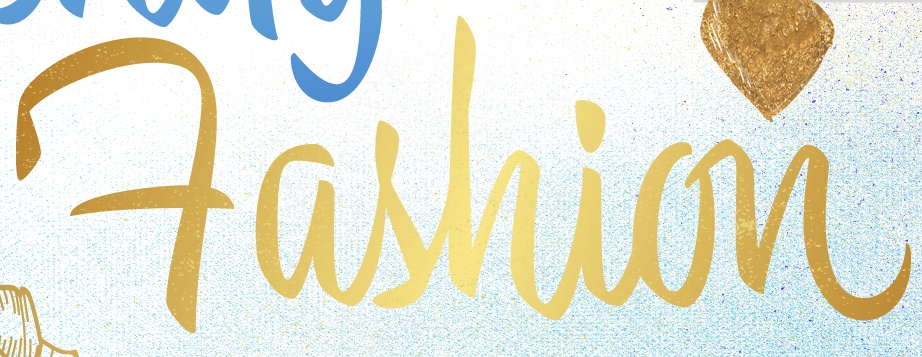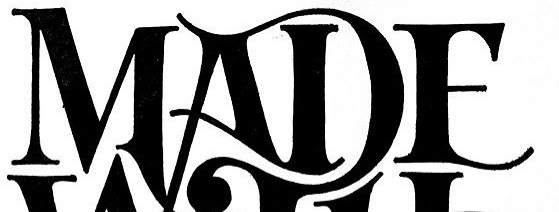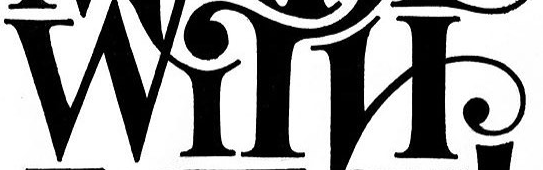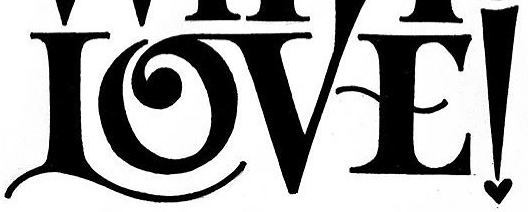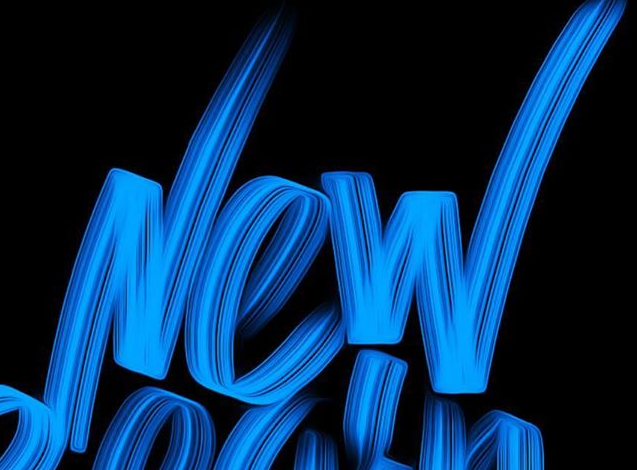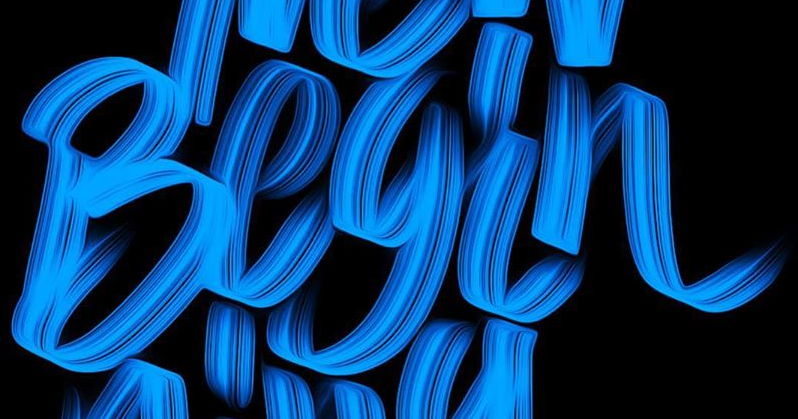What words are shown in these images in order, separated by a semicolon? Fashion; MADE; WITH; LOVE!; New; Begin 